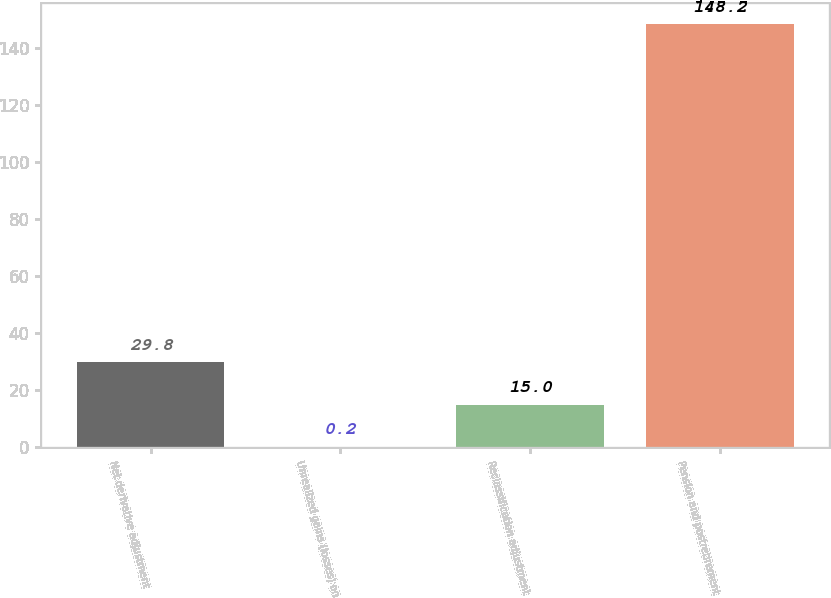<chart> <loc_0><loc_0><loc_500><loc_500><bar_chart><fcel>Net derivative adjustment<fcel>Unrealized gains (losses) on<fcel>Reclassification adjustment<fcel>Pension and postretirement<nl><fcel>29.8<fcel>0.2<fcel>15<fcel>148.2<nl></chart> 